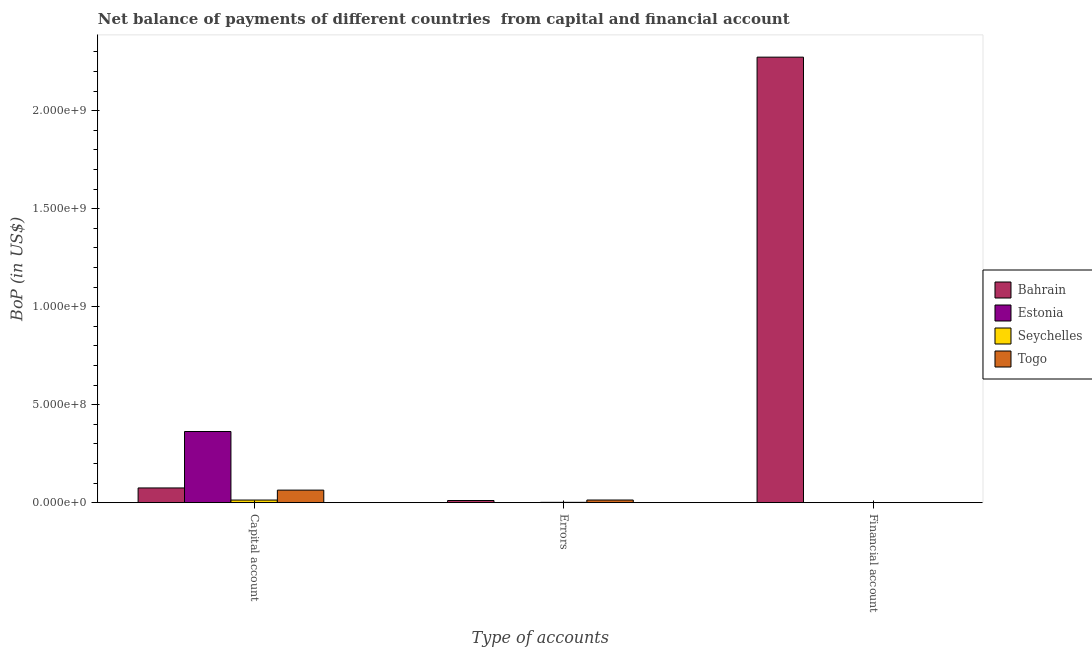Are the number of bars on each tick of the X-axis equal?
Ensure brevity in your answer.  No. What is the label of the 2nd group of bars from the left?
Give a very brief answer. Errors. What is the amount of financial account in Seychelles?
Provide a succinct answer. 0. Across all countries, what is the maximum amount of net capital account?
Your answer should be compact. 3.63e+08. In which country was the amount of net capital account maximum?
Provide a short and direct response. Estonia. What is the total amount of errors in the graph?
Your answer should be very brief. 2.60e+07. What is the difference between the amount of errors in Bahrain and that in Togo?
Offer a terse response. -2.44e+06. What is the difference between the amount of financial account in Estonia and the amount of net capital account in Togo?
Offer a very short reply. -6.40e+07. What is the average amount of errors per country?
Give a very brief answer. 6.49e+06. What is the difference between the amount of net capital account and amount of financial account in Bahrain?
Ensure brevity in your answer.  -2.20e+09. In how many countries, is the amount of net capital account greater than 800000000 US$?
Your response must be concise. 0. Is the amount of net capital account in Estonia less than that in Togo?
Provide a succinct answer. No. Is the difference between the amount of net capital account in Bahrain and Seychelles greater than the difference between the amount of errors in Bahrain and Seychelles?
Your answer should be very brief. Yes. What is the difference between the highest and the second highest amount of net capital account?
Offer a very short reply. 2.88e+08. What is the difference between the highest and the lowest amount of net capital account?
Provide a succinct answer. 3.50e+08. In how many countries, is the amount of net capital account greater than the average amount of net capital account taken over all countries?
Keep it short and to the point. 1. How many bars are there?
Make the answer very short. 8. What is the difference between two consecutive major ticks on the Y-axis?
Ensure brevity in your answer.  5.00e+08. Does the graph contain any zero values?
Make the answer very short. Yes. Does the graph contain grids?
Your answer should be compact. No. Where does the legend appear in the graph?
Your answer should be compact. Center right. How many legend labels are there?
Provide a succinct answer. 4. What is the title of the graph?
Offer a terse response. Net balance of payments of different countries  from capital and financial account. What is the label or title of the X-axis?
Offer a very short reply. Type of accounts. What is the label or title of the Y-axis?
Ensure brevity in your answer.  BoP (in US$). What is the BoP (in US$) in Bahrain in Capital account?
Make the answer very short. 7.50e+07. What is the BoP (in US$) of Estonia in Capital account?
Ensure brevity in your answer.  3.63e+08. What is the BoP (in US$) in Seychelles in Capital account?
Your answer should be very brief. 1.32e+07. What is the BoP (in US$) of Togo in Capital account?
Provide a succinct answer. 6.40e+07. What is the BoP (in US$) of Bahrain in Errors?
Your answer should be compact. 1.10e+07. What is the BoP (in US$) in Estonia in Errors?
Provide a short and direct response. 0. What is the BoP (in US$) in Seychelles in Errors?
Offer a terse response. 1.60e+06. What is the BoP (in US$) in Togo in Errors?
Offer a very short reply. 1.34e+07. What is the BoP (in US$) in Bahrain in Financial account?
Your answer should be compact. 2.27e+09. What is the BoP (in US$) in Seychelles in Financial account?
Ensure brevity in your answer.  0. Across all Type of accounts, what is the maximum BoP (in US$) in Bahrain?
Give a very brief answer. 2.27e+09. Across all Type of accounts, what is the maximum BoP (in US$) in Estonia?
Keep it short and to the point. 3.63e+08. Across all Type of accounts, what is the maximum BoP (in US$) in Seychelles?
Provide a short and direct response. 1.32e+07. Across all Type of accounts, what is the maximum BoP (in US$) of Togo?
Give a very brief answer. 6.40e+07. Across all Type of accounts, what is the minimum BoP (in US$) of Bahrain?
Make the answer very short. 1.10e+07. Across all Type of accounts, what is the minimum BoP (in US$) in Estonia?
Provide a short and direct response. 0. What is the total BoP (in US$) of Bahrain in the graph?
Your answer should be very brief. 2.36e+09. What is the total BoP (in US$) in Estonia in the graph?
Your answer should be compact. 3.63e+08. What is the total BoP (in US$) in Seychelles in the graph?
Make the answer very short. 1.48e+07. What is the total BoP (in US$) of Togo in the graph?
Offer a terse response. 7.74e+07. What is the difference between the BoP (in US$) in Bahrain in Capital account and that in Errors?
Provide a succinct answer. 6.40e+07. What is the difference between the BoP (in US$) of Seychelles in Capital account and that in Errors?
Provide a short and direct response. 1.16e+07. What is the difference between the BoP (in US$) of Togo in Capital account and that in Errors?
Your answer should be very brief. 5.06e+07. What is the difference between the BoP (in US$) in Bahrain in Capital account and that in Financial account?
Provide a short and direct response. -2.20e+09. What is the difference between the BoP (in US$) in Bahrain in Errors and that in Financial account?
Your response must be concise. -2.26e+09. What is the difference between the BoP (in US$) in Bahrain in Capital account and the BoP (in US$) in Seychelles in Errors?
Ensure brevity in your answer.  7.34e+07. What is the difference between the BoP (in US$) in Bahrain in Capital account and the BoP (in US$) in Togo in Errors?
Offer a very short reply. 6.16e+07. What is the difference between the BoP (in US$) of Estonia in Capital account and the BoP (in US$) of Seychelles in Errors?
Make the answer very short. 3.61e+08. What is the difference between the BoP (in US$) of Estonia in Capital account and the BoP (in US$) of Togo in Errors?
Provide a short and direct response. 3.50e+08. What is the difference between the BoP (in US$) in Seychelles in Capital account and the BoP (in US$) in Togo in Errors?
Your response must be concise. -1.54e+05. What is the average BoP (in US$) in Bahrain per Type of accounts?
Offer a terse response. 7.86e+08. What is the average BoP (in US$) of Estonia per Type of accounts?
Your answer should be very brief. 1.21e+08. What is the average BoP (in US$) of Seychelles per Type of accounts?
Make the answer very short. 4.95e+06. What is the average BoP (in US$) of Togo per Type of accounts?
Give a very brief answer. 2.58e+07. What is the difference between the BoP (in US$) of Bahrain and BoP (in US$) of Estonia in Capital account?
Make the answer very short. -2.88e+08. What is the difference between the BoP (in US$) of Bahrain and BoP (in US$) of Seychelles in Capital account?
Provide a succinct answer. 6.18e+07. What is the difference between the BoP (in US$) in Bahrain and BoP (in US$) in Togo in Capital account?
Provide a succinct answer. 1.10e+07. What is the difference between the BoP (in US$) in Estonia and BoP (in US$) in Seychelles in Capital account?
Provide a short and direct response. 3.50e+08. What is the difference between the BoP (in US$) of Estonia and BoP (in US$) of Togo in Capital account?
Offer a very short reply. 2.99e+08. What is the difference between the BoP (in US$) in Seychelles and BoP (in US$) in Togo in Capital account?
Keep it short and to the point. -5.07e+07. What is the difference between the BoP (in US$) in Bahrain and BoP (in US$) in Seychelles in Errors?
Offer a terse response. 9.35e+06. What is the difference between the BoP (in US$) of Bahrain and BoP (in US$) of Togo in Errors?
Provide a short and direct response. -2.44e+06. What is the difference between the BoP (in US$) in Seychelles and BoP (in US$) in Togo in Errors?
Offer a very short reply. -1.18e+07. What is the ratio of the BoP (in US$) of Bahrain in Capital account to that in Errors?
Your answer should be compact. 6.85. What is the ratio of the BoP (in US$) of Seychelles in Capital account to that in Errors?
Your answer should be very brief. 8.26. What is the ratio of the BoP (in US$) in Togo in Capital account to that in Errors?
Your response must be concise. 4.78. What is the ratio of the BoP (in US$) of Bahrain in Capital account to that in Financial account?
Your response must be concise. 0.03. What is the ratio of the BoP (in US$) in Bahrain in Errors to that in Financial account?
Your answer should be very brief. 0. What is the difference between the highest and the second highest BoP (in US$) in Bahrain?
Keep it short and to the point. 2.20e+09. What is the difference between the highest and the lowest BoP (in US$) of Bahrain?
Make the answer very short. 2.26e+09. What is the difference between the highest and the lowest BoP (in US$) of Estonia?
Keep it short and to the point. 3.63e+08. What is the difference between the highest and the lowest BoP (in US$) of Seychelles?
Keep it short and to the point. 1.32e+07. What is the difference between the highest and the lowest BoP (in US$) in Togo?
Provide a short and direct response. 6.40e+07. 